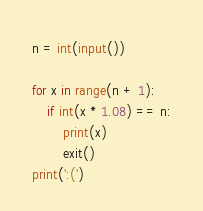<code> <loc_0><loc_0><loc_500><loc_500><_Python_>n = int(input())

for x in range(n + 1):
    if int(x * 1.08) == n:
        print(x)
        exit()
print(':(')
</code> 